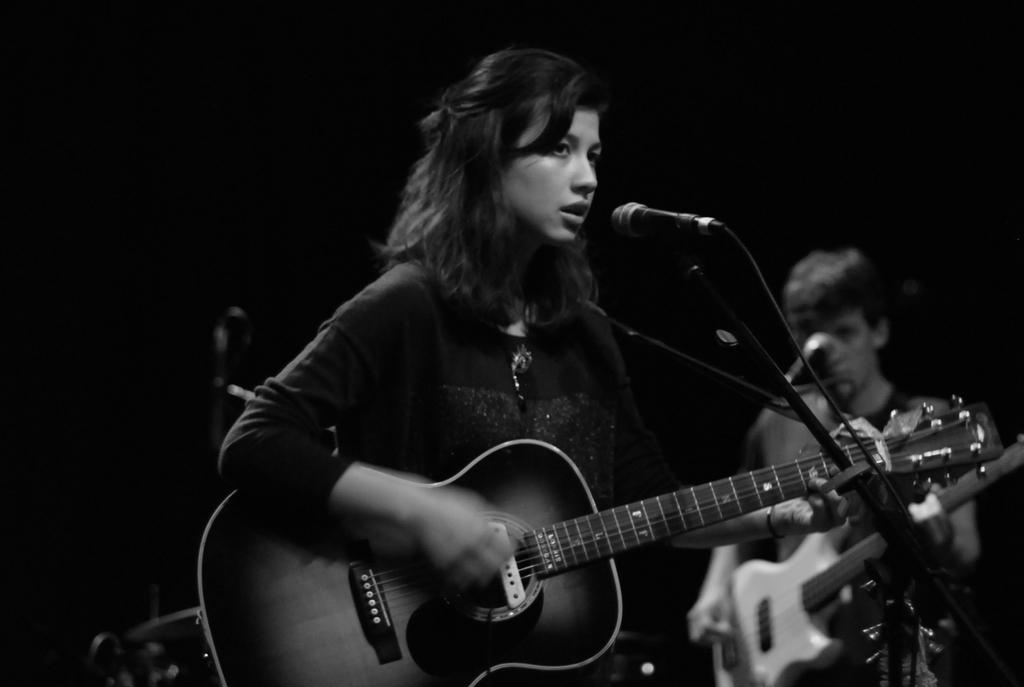Can you describe this image briefly? In the foreground of this image, there is a woman standing and playing a guitar in front of a mic with the stand and a man standing and holding a guitar in front of a mic and there is a dark background. This image is a black and white image. 